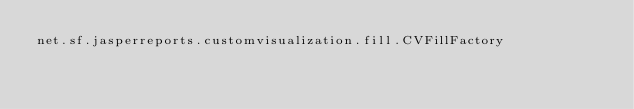<code> <loc_0><loc_0><loc_500><loc_500><_Rust_>net.sf.jasperreports.customvisualization.fill.CVFillFactory
</code> 